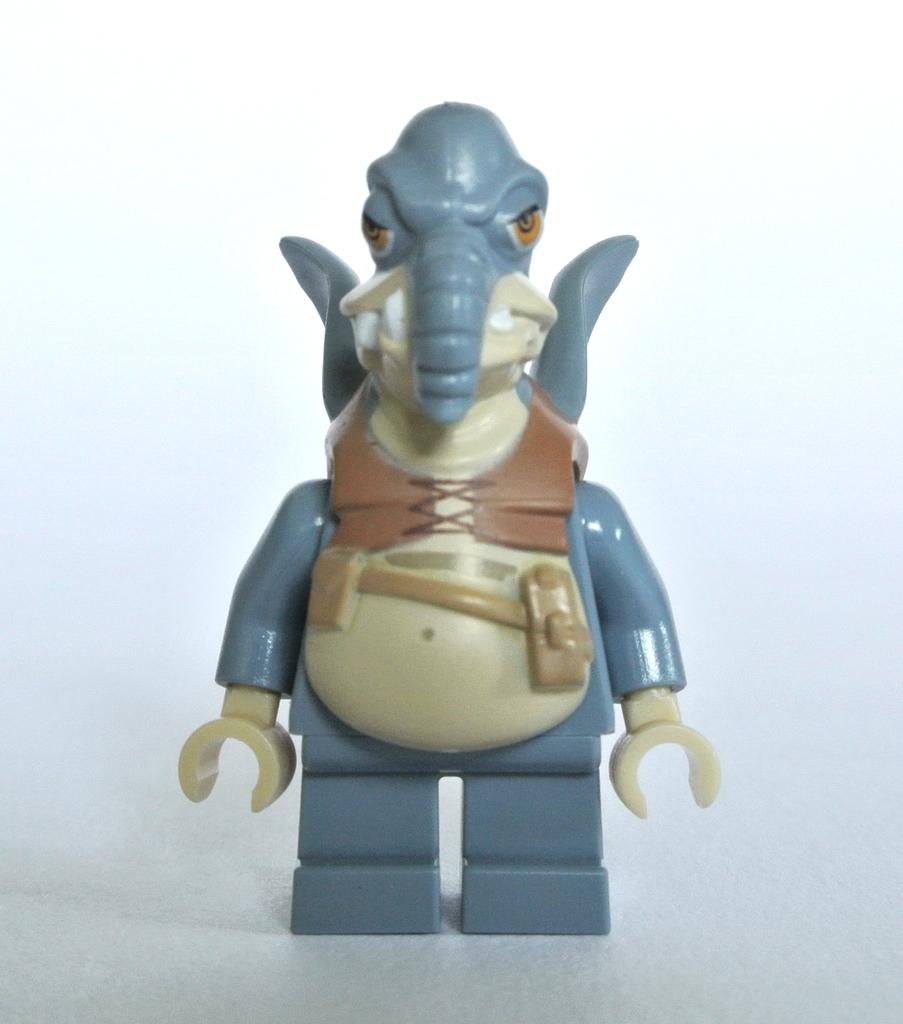What object is present in the image? There is a toy in the image. What color is the surface on which the toy is placed? The toy is on a white color surface. What colors can be seen on the toy? The toy has blue, brown, and cream colors. What is the color of the background in the image? The background of the image is white. How does the cork affect the expansion of the toy in the image? There is no cork present in the image, so it cannot affect the expansion of the toy. 